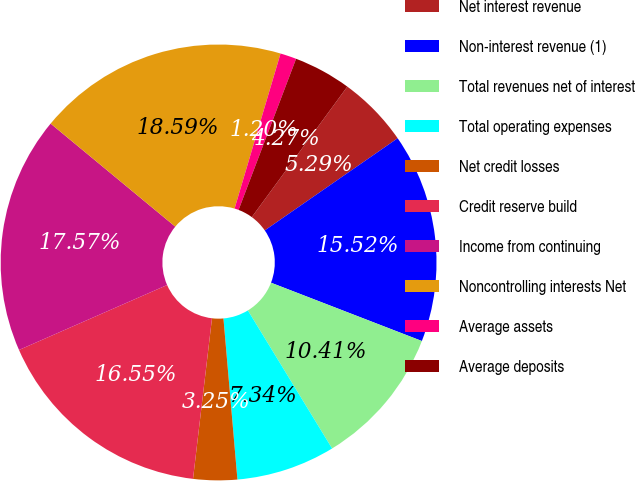<chart> <loc_0><loc_0><loc_500><loc_500><pie_chart><fcel>Net interest revenue<fcel>Non-interest revenue (1)<fcel>Total revenues net of interest<fcel>Total operating expenses<fcel>Net credit losses<fcel>Credit reserve build<fcel>Income from continuing<fcel>Noncontrolling interests Net<fcel>Average assets<fcel>Average deposits<nl><fcel>5.29%<fcel>15.52%<fcel>10.41%<fcel>7.34%<fcel>3.25%<fcel>16.55%<fcel>17.57%<fcel>18.59%<fcel>1.2%<fcel>4.27%<nl></chart> 